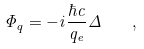<formula> <loc_0><loc_0><loc_500><loc_500>\Phi _ { q } = - i \frac { \hbar { c } } { q _ { e } } \Delta \quad ,</formula> 